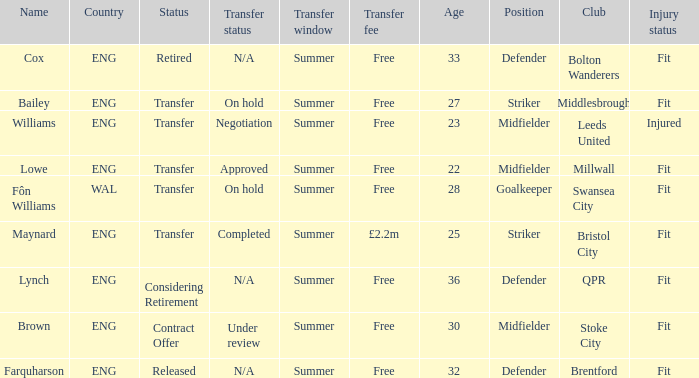What is the status of the ENG Country with the name of Farquharson? Released. Can you parse all the data within this table? {'header': ['Name', 'Country', 'Status', 'Transfer status', 'Transfer window', 'Transfer fee', 'Age', 'Position', 'Club', 'Injury status'], 'rows': [['Cox', 'ENG', 'Retired', 'N/A', 'Summer', 'Free', '33', 'Defender', 'Bolton Wanderers', 'Fit'], ['Bailey', 'ENG', 'Transfer', 'On hold', 'Summer', 'Free', '27', 'Striker', 'Middlesbrough', 'Fit'], ['Williams', 'ENG', 'Transfer', 'Negotiation', 'Summer', 'Free', '23', 'Midfielder', 'Leeds United', 'Injured'], ['Lowe', 'ENG', 'Transfer', 'Approved', 'Summer', 'Free', '22', 'Midfielder', 'Millwall', 'Fit'], ['Fôn Williams', 'WAL', 'Transfer', 'On hold', 'Summer', 'Free', '28', 'Goalkeeper', 'Swansea City', 'Fit'], ['Maynard', 'ENG', 'Transfer', 'Completed', 'Summer', '£2.2m', '25', 'Striker', 'Bristol City', 'Fit'], ['Lynch', 'ENG', 'Considering Retirement', 'N/A', 'Summer', 'Free', '36', 'Defender', 'QPR', 'Fit'], ['Brown', 'ENG', 'Contract Offer', 'Under review', 'Summer', 'Free', '30', 'Midfielder', 'Stoke City', 'Fit'], ['Farquharson', 'ENG', 'Released', 'N/A', 'Summer', 'Free', '32', 'Defender', 'Brentford', 'Fit']]} 